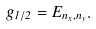Convert formula to latex. <formula><loc_0><loc_0><loc_500><loc_500>g _ { 1 / 2 } = E _ { n _ { x } , n _ { y } } .</formula> 